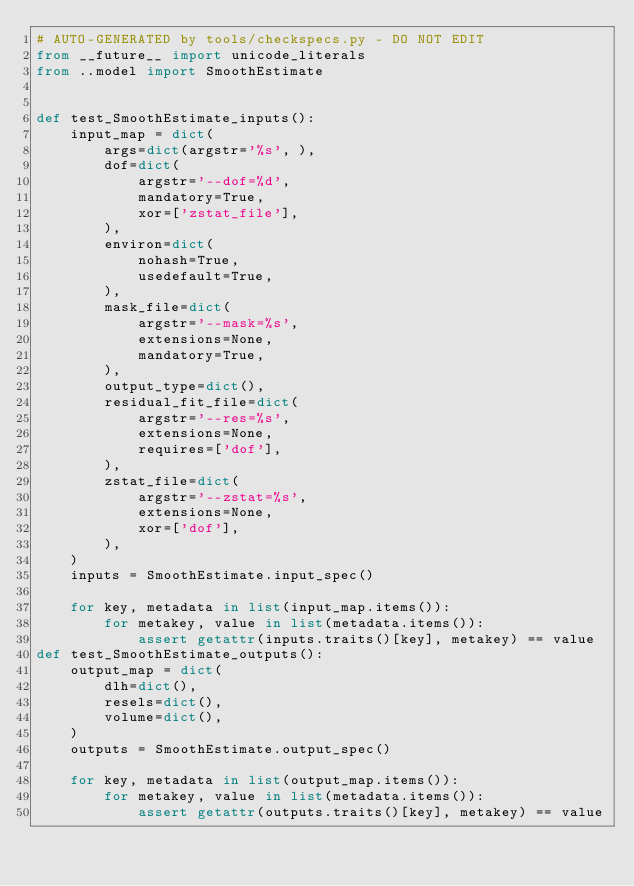<code> <loc_0><loc_0><loc_500><loc_500><_Python_># AUTO-GENERATED by tools/checkspecs.py - DO NOT EDIT
from __future__ import unicode_literals
from ..model import SmoothEstimate


def test_SmoothEstimate_inputs():
    input_map = dict(
        args=dict(argstr='%s', ),
        dof=dict(
            argstr='--dof=%d',
            mandatory=True,
            xor=['zstat_file'],
        ),
        environ=dict(
            nohash=True,
            usedefault=True,
        ),
        mask_file=dict(
            argstr='--mask=%s',
            extensions=None,
            mandatory=True,
        ),
        output_type=dict(),
        residual_fit_file=dict(
            argstr='--res=%s',
            extensions=None,
            requires=['dof'],
        ),
        zstat_file=dict(
            argstr='--zstat=%s',
            extensions=None,
            xor=['dof'],
        ),
    )
    inputs = SmoothEstimate.input_spec()

    for key, metadata in list(input_map.items()):
        for metakey, value in list(metadata.items()):
            assert getattr(inputs.traits()[key], metakey) == value
def test_SmoothEstimate_outputs():
    output_map = dict(
        dlh=dict(),
        resels=dict(),
        volume=dict(),
    )
    outputs = SmoothEstimate.output_spec()

    for key, metadata in list(output_map.items()):
        for metakey, value in list(metadata.items()):
            assert getattr(outputs.traits()[key], metakey) == value
</code> 